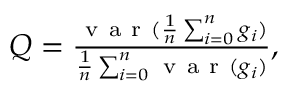Convert formula to latex. <formula><loc_0><loc_0><loc_500><loc_500>\begin{array} { r } { Q = \frac { v a r ( \frac { 1 } { n } \sum _ { i = 0 } ^ { n } g _ { i } ) } { \frac { 1 } { n } \sum _ { i = 0 } ^ { n } v a r ( g _ { i } ) } , } \end{array}</formula> 